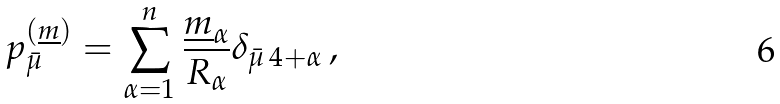Convert formula to latex. <formula><loc_0><loc_0><loc_500><loc_500>p _ { \bar { \mu } } ^ { ( \underline { m } ) } = \sum ^ { n } _ { \alpha = 1 } \frac { \underline { m } _ { \alpha } } { R _ { \alpha } } \delta _ { \bar { \mu } \, { 4 + \alpha } } \, ,</formula> 